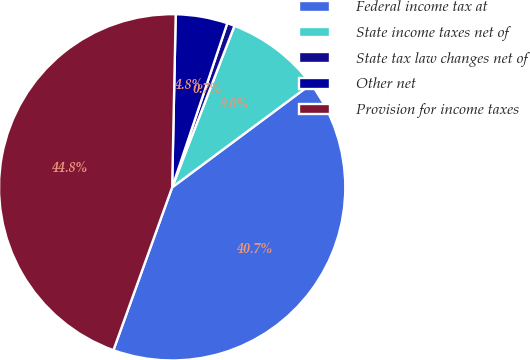Convert chart to OTSL. <chart><loc_0><loc_0><loc_500><loc_500><pie_chart><fcel>Federal income tax at<fcel>State income taxes net of<fcel>State tax law changes net of<fcel>Other net<fcel>Provision for income taxes<nl><fcel>40.68%<fcel>8.97%<fcel>0.7%<fcel>4.83%<fcel>44.82%<nl></chart> 